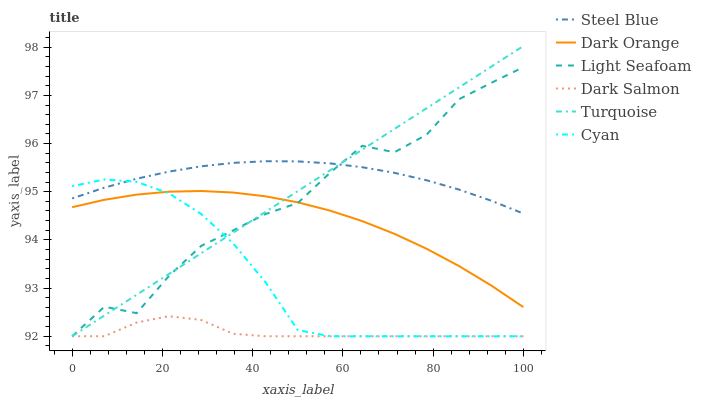Does Dark Salmon have the minimum area under the curve?
Answer yes or no. Yes. Does Steel Blue have the maximum area under the curve?
Answer yes or no. Yes. Does Turquoise have the minimum area under the curve?
Answer yes or no. No. Does Turquoise have the maximum area under the curve?
Answer yes or no. No. Is Turquoise the smoothest?
Answer yes or no. Yes. Is Light Seafoam the roughest?
Answer yes or no. Yes. Is Steel Blue the smoothest?
Answer yes or no. No. Is Steel Blue the roughest?
Answer yes or no. No. Does Turquoise have the lowest value?
Answer yes or no. Yes. Does Steel Blue have the lowest value?
Answer yes or no. No. Does Turquoise have the highest value?
Answer yes or no. Yes. Does Steel Blue have the highest value?
Answer yes or no. No. Is Dark Salmon less than Steel Blue?
Answer yes or no. Yes. Is Dark Orange greater than Dark Salmon?
Answer yes or no. Yes. Does Light Seafoam intersect Cyan?
Answer yes or no. Yes. Is Light Seafoam less than Cyan?
Answer yes or no. No. Is Light Seafoam greater than Cyan?
Answer yes or no. No. Does Dark Salmon intersect Steel Blue?
Answer yes or no. No. 